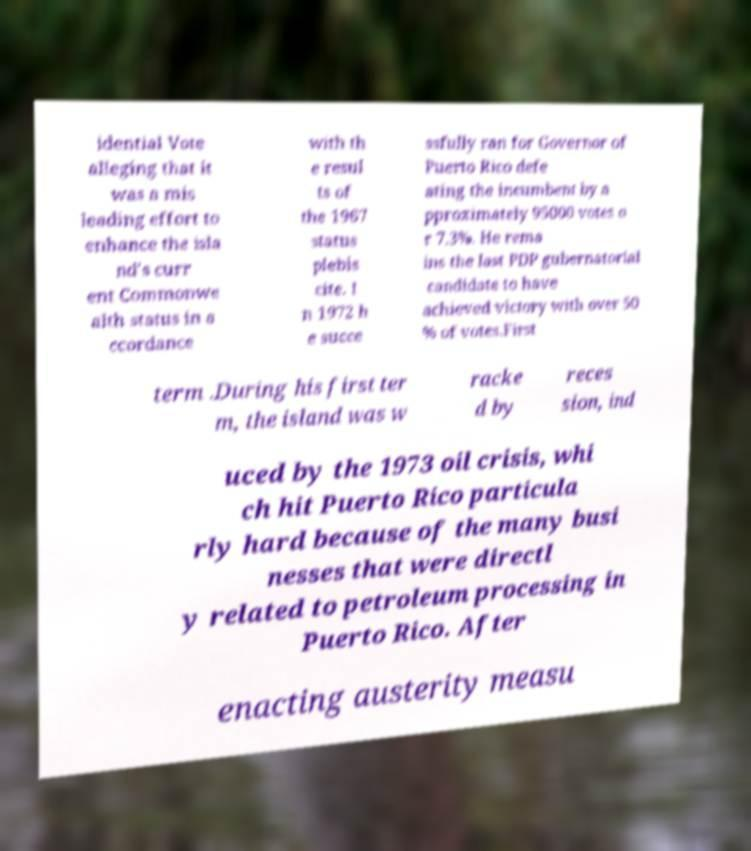Can you read and provide the text displayed in the image?This photo seems to have some interesting text. Can you extract and type it out for me? idential Vote alleging that it was a mis leading effort to enhance the isla nd's curr ent Commonwe alth status in a ccordance with th e resul ts of the 1967 status plebis cite. I n 1972 h e succe ssfully ran for Governor of Puerto Rico defe ating the incumbent by a pproximately 95000 votes o r 7.3%. He rema ins the last PDP gubernatorial candidate to have achieved victory with over 50 % of votes.First term .During his first ter m, the island was w racke d by reces sion, ind uced by the 1973 oil crisis, whi ch hit Puerto Rico particula rly hard because of the many busi nesses that were directl y related to petroleum processing in Puerto Rico. After enacting austerity measu 